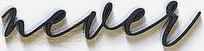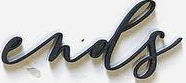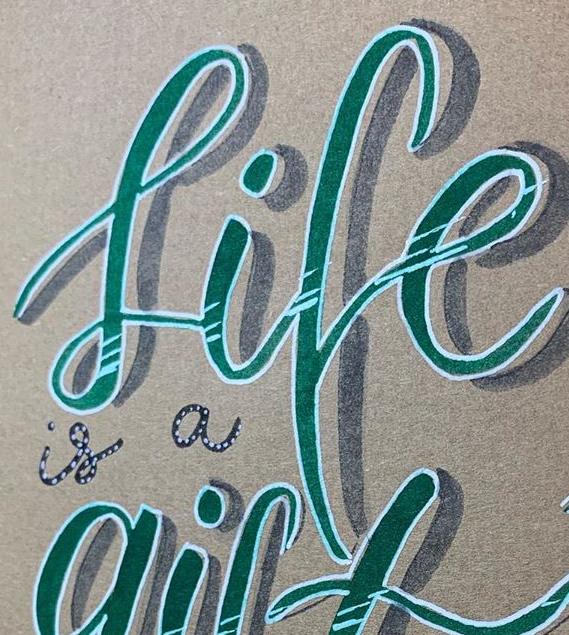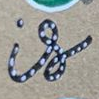Identify the words shown in these images in order, separated by a semicolon. never; ends; life; is 